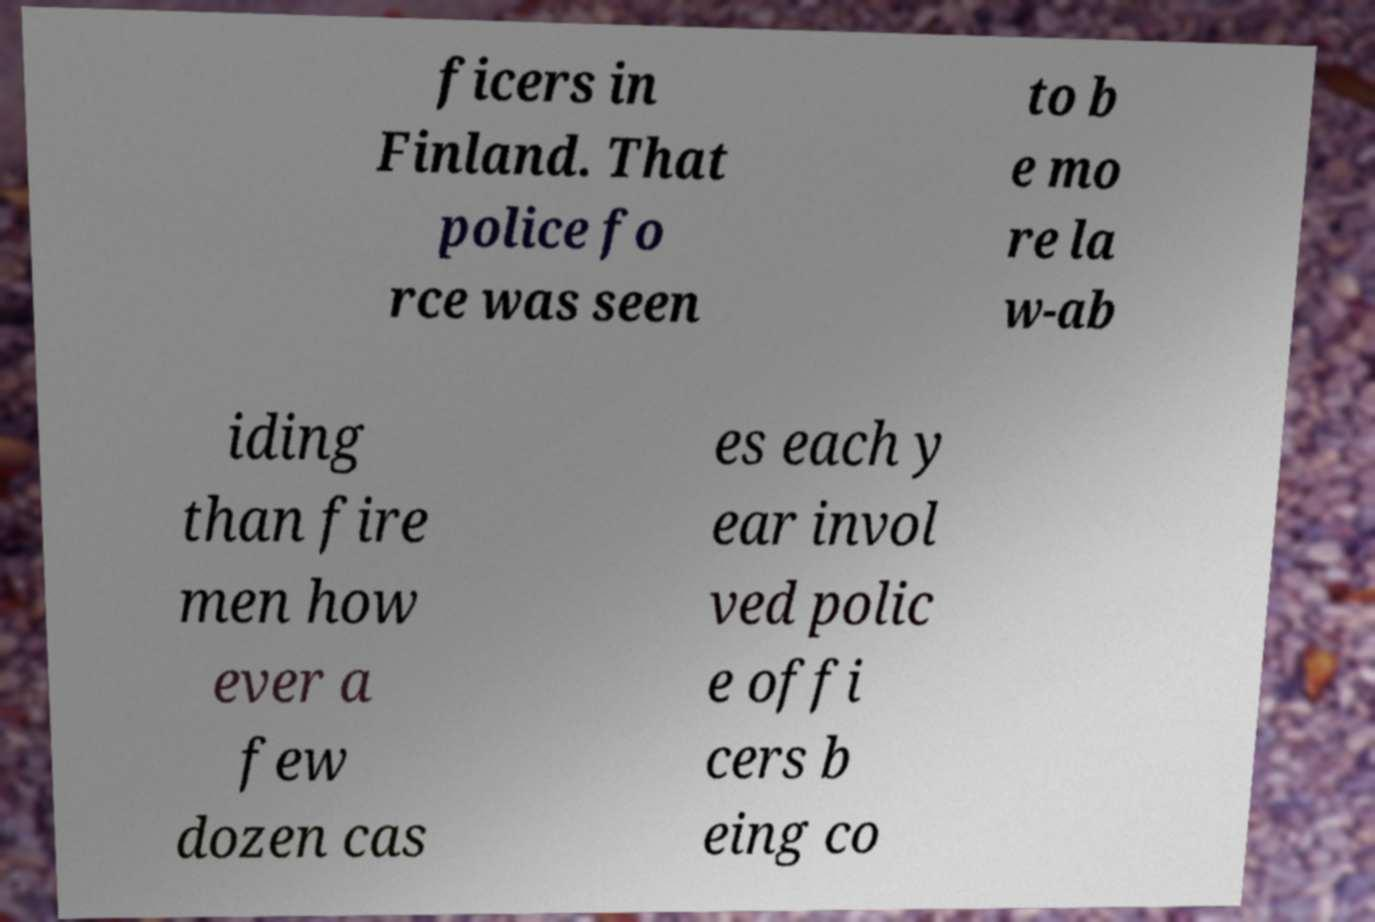Could you extract and type out the text from this image? ficers in Finland. That police fo rce was seen to b e mo re la w-ab iding than fire men how ever a few dozen cas es each y ear invol ved polic e offi cers b eing co 